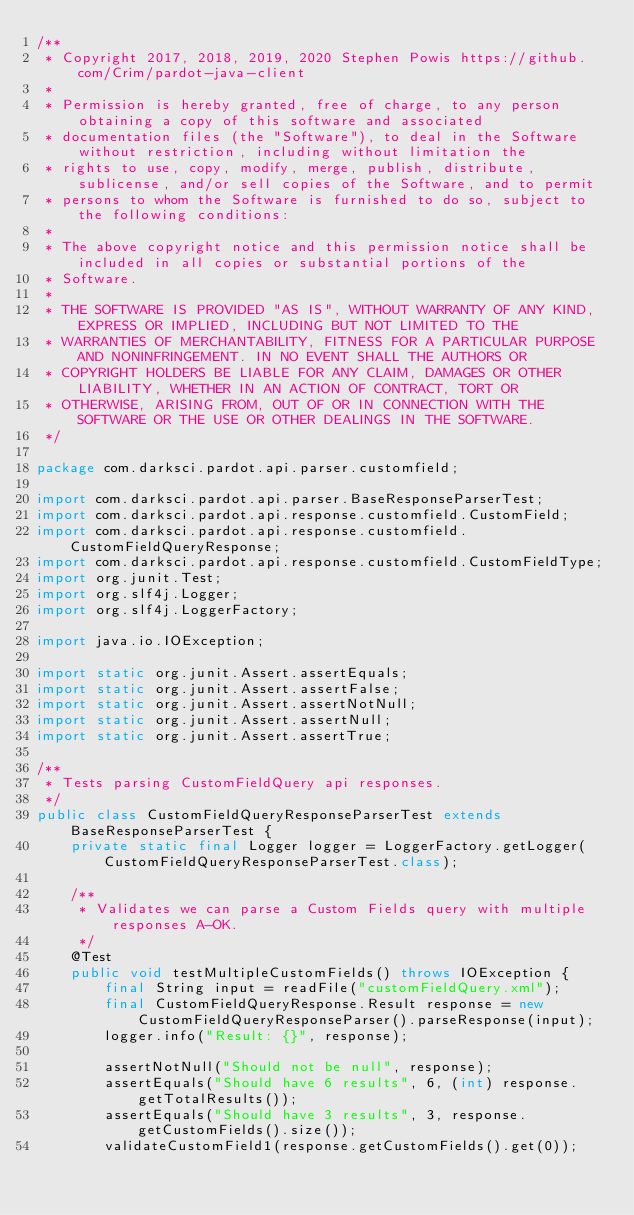Convert code to text. <code><loc_0><loc_0><loc_500><loc_500><_Java_>/**
 * Copyright 2017, 2018, 2019, 2020 Stephen Powis https://github.com/Crim/pardot-java-client
 *
 * Permission is hereby granted, free of charge, to any person obtaining a copy of this software and associated
 * documentation files (the "Software"), to deal in the Software without restriction, including without limitation the
 * rights to use, copy, modify, merge, publish, distribute, sublicense, and/or sell copies of the Software, and to permit
 * persons to whom the Software is furnished to do so, subject to the following conditions:
 *
 * The above copyright notice and this permission notice shall be included in all copies or substantial portions of the
 * Software.
 *
 * THE SOFTWARE IS PROVIDED "AS IS", WITHOUT WARRANTY OF ANY KIND, EXPRESS OR IMPLIED, INCLUDING BUT NOT LIMITED TO THE
 * WARRANTIES OF MERCHANTABILITY, FITNESS FOR A PARTICULAR PURPOSE AND NONINFRINGEMENT. IN NO EVENT SHALL THE AUTHORS OR
 * COPYRIGHT HOLDERS BE LIABLE FOR ANY CLAIM, DAMAGES OR OTHER LIABILITY, WHETHER IN AN ACTION OF CONTRACT, TORT OR
 * OTHERWISE, ARISING FROM, OUT OF OR IN CONNECTION WITH THE SOFTWARE OR THE USE OR OTHER DEALINGS IN THE SOFTWARE.
 */

package com.darksci.pardot.api.parser.customfield;

import com.darksci.pardot.api.parser.BaseResponseParserTest;
import com.darksci.pardot.api.response.customfield.CustomField;
import com.darksci.pardot.api.response.customfield.CustomFieldQueryResponse;
import com.darksci.pardot.api.response.customfield.CustomFieldType;
import org.junit.Test;
import org.slf4j.Logger;
import org.slf4j.LoggerFactory;

import java.io.IOException;

import static org.junit.Assert.assertEquals;
import static org.junit.Assert.assertFalse;
import static org.junit.Assert.assertNotNull;
import static org.junit.Assert.assertNull;
import static org.junit.Assert.assertTrue;

/**
 * Tests parsing CustomFieldQuery api responses.
 */
public class CustomFieldQueryResponseParserTest extends BaseResponseParserTest {
    private static final Logger logger = LoggerFactory.getLogger(CustomFieldQueryResponseParserTest.class);

    /**
     * Validates we can parse a Custom Fields query with multiple responses A-OK.
     */
    @Test
    public void testMultipleCustomFields() throws IOException {
        final String input = readFile("customFieldQuery.xml");
        final CustomFieldQueryResponse.Result response = new CustomFieldQueryResponseParser().parseResponse(input);
        logger.info("Result: {}", response);

        assertNotNull("Should not be null", response);
        assertEquals("Should have 6 results", 6, (int) response.getTotalResults());
        assertEquals("Should have 3 results", 3, response.getCustomFields().size());
        validateCustomField1(response.getCustomFields().get(0));</code> 